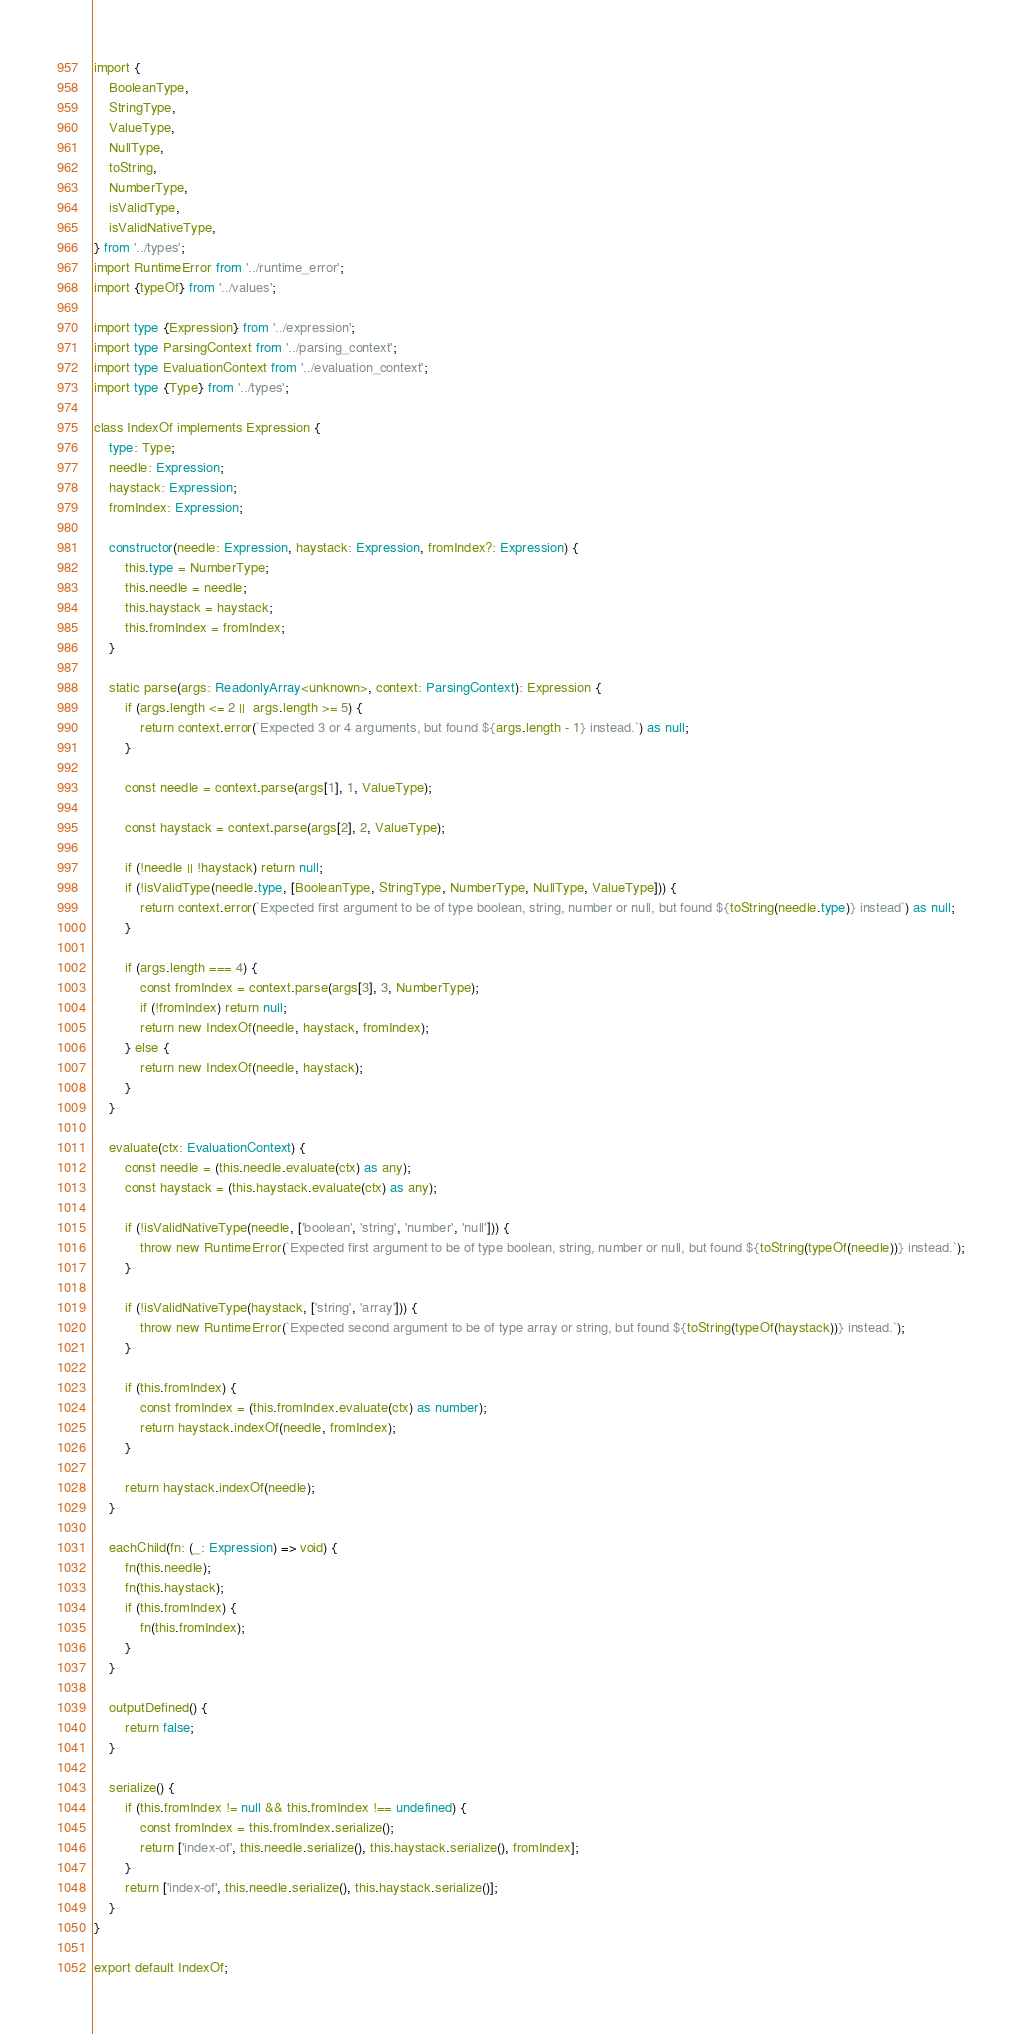Convert code to text. <code><loc_0><loc_0><loc_500><loc_500><_TypeScript_>import {
    BooleanType,
    StringType,
    ValueType,
    NullType,
    toString,
    NumberType,
    isValidType,
    isValidNativeType,
} from '../types';
import RuntimeError from '../runtime_error';
import {typeOf} from '../values';

import type {Expression} from '../expression';
import type ParsingContext from '../parsing_context';
import type EvaluationContext from '../evaluation_context';
import type {Type} from '../types';

class IndexOf implements Expression {
    type: Type;
    needle: Expression;
    haystack: Expression;
    fromIndex: Expression;

    constructor(needle: Expression, haystack: Expression, fromIndex?: Expression) {
        this.type = NumberType;
        this.needle = needle;
        this.haystack = haystack;
        this.fromIndex = fromIndex;
    }

    static parse(args: ReadonlyArray<unknown>, context: ParsingContext): Expression {
        if (args.length <= 2 ||  args.length >= 5) {
            return context.error(`Expected 3 or 4 arguments, but found ${args.length - 1} instead.`) as null;
        }

        const needle = context.parse(args[1], 1, ValueType);

        const haystack = context.parse(args[2], 2, ValueType);

        if (!needle || !haystack) return null;
        if (!isValidType(needle.type, [BooleanType, StringType, NumberType, NullType, ValueType])) {
            return context.error(`Expected first argument to be of type boolean, string, number or null, but found ${toString(needle.type)} instead`) as null;
        }

        if (args.length === 4) {
            const fromIndex = context.parse(args[3], 3, NumberType);
            if (!fromIndex) return null;
            return new IndexOf(needle, haystack, fromIndex);
        } else {
            return new IndexOf(needle, haystack);
        }
    }

    evaluate(ctx: EvaluationContext) {
        const needle = (this.needle.evaluate(ctx) as any);
        const haystack = (this.haystack.evaluate(ctx) as any);

        if (!isValidNativeType(needle, ['boolean', 'string', 'number', 'null'])) {
            throw new RuntimeError(`Expected first argument to be of type boolean, string, number or null, but found ${toString(typeOf(needle))} instead.`);
        }

        if (!isValidNativeType(haystack, ['string', 'array'])) {
            throw new RuntimeError(`Expected second argument to be of type array or string, but found ${toString(typeOf(haystack))} instead.`);
        }

        if (this.fromIndex) {
            const fromIndex = (this.fromIndex.evaluate(ctx) as number);
            return haystack.indexOf(needle, fromIndex);
        }

        return haystack.indexOf(needle);
    }

    eachChild(fn: (_: Expression) => void) {
        fn(this.needle);
        fn(this.haystack);
        if (this.fromIndex) {
            fn(this.fromIndex);
        }
    }

    outputDefined() {
        return false;
    }

    serialize() {
        if (this.fromIndex != null && this.fromIndex !== undefined) {
            const fromIndex = this.fromIndex.serialize();
            return ['index-of', this.needle.serialize(), this.haystack.serialize(), fromIndex];
        }
        return ['index-of', this.needle.serialize(), this.haystack.serialize()];
    }
}

export default IndexOf;
</code> 